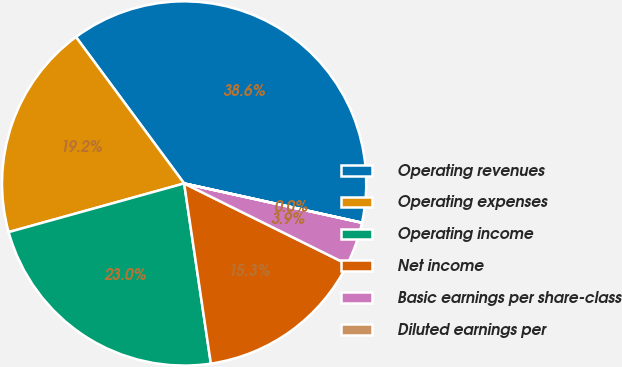Convert chart. <chart><loc_0><loc_0><loc_500><loc_500><pie_chart><fcel>Operating revenues<fcel>Operating expenses<fcel>Operating income<fcel>Net income<fcel>Basic earnings per share-class<fcel>Diluted earnings per<nl><fcel>38.58%<fcel>19.18%<fcel>23.04%<fcel>15.33%<fcel>3.86%<fcel>0.01%<nl></chart> 